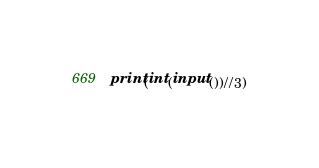<code> <loc_0><loc_0><loc_500><loc_500><_Python_>print(int(input())//3)</code> 